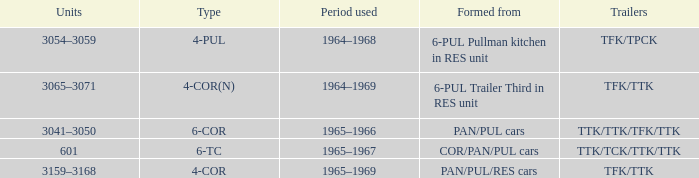What is the third type created from a 6-pul trailer in the res unit? 4-COR(N). 